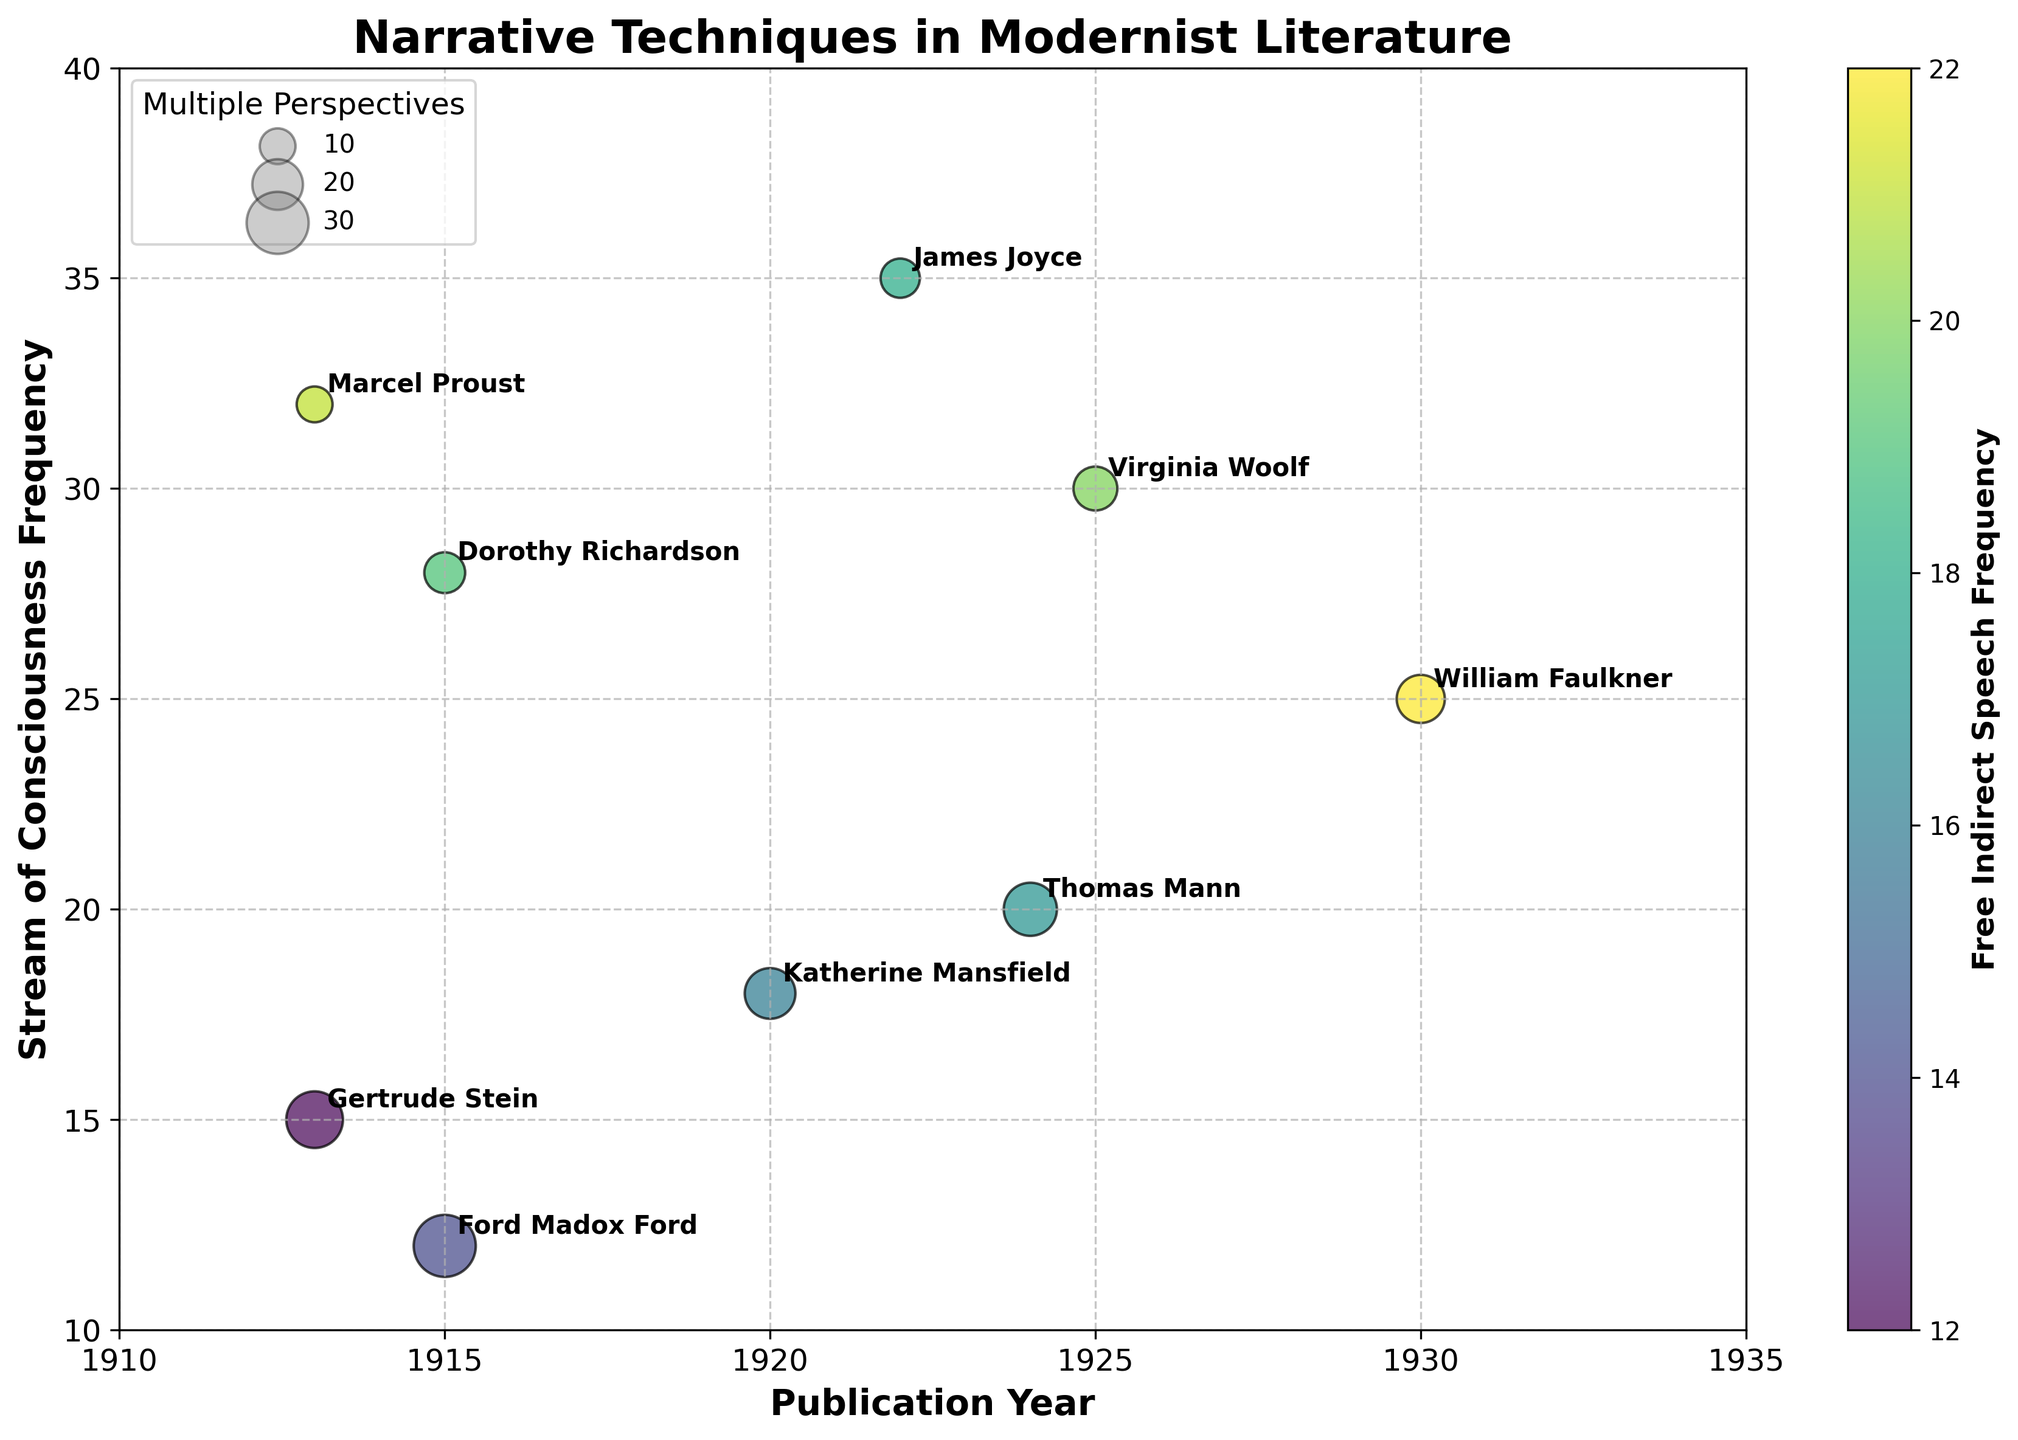What is the title of the figure? The title of the figure is usually placed at the top and it is meant to give a brief summary of what the chart conveys.
Answer: Narrative Techniques in Modernist Literature Which axis represents the Publication Year? The x-axis typically represents the independent variable, and here it is labeled as 'Publication Year'.
Answer: x-axis How many authors have data points in the figure? Each data point corresponds to an author, and we can count each label on the figure to determine the number of authors.
Answer: 9 Who used Stream of Consciousness most frequently? By identifying the highest value on the y-axis and checking the label, we find the author who utilized Stream of Consciousness most frequently. The highest value, 35, corresponds to James Joyce.
Answer: James Joyce Which author has the largest bubble size? The size of the bubbles represents 'Multiple Perspectives'; the largest bubble can be visually identified, which corresponds to the highest value. Ford Madox Ford has the largest bubble with a size of 30.
Answer: Ford Madox Ford How is Free Indirect Speech represented in the figure? Free Indirect Speech frequency is encoded using bubble colors, and a colorbar on the right side of the chart explains how the colors correspond to different values.
Answer: Bubble colors What is the range of the Stream of Consciousness frequency? To determine this range, we look for the minimum and maximum values of the y-axis, where Stream of Consciousness frequency is plotted. The range extends from about 10 to 35.
Answer: 10 to 35 Which year has the highest average use of Stream of Consciousness across authors? Calculate the average Stream of Consciousness for each unique year by summing the values and dividing by the number of authors for that year, check which year has the highest value. For instance, in 1925 Virginia Woolf has 30, and it is the only value for that year, thus 1925 is the highest year with an average of 30.
Answer: 1925 Does Katherine Mansfield have more instances of Multiple Perspectives than Virginia Woolf? Compare the size of the bubbles representing these authors. Katherine Mansfield's Multiple Perspectives value is 20, which is more than Virginia Woolf's 15.
Answer: Yes What is the general relationship between Stream of Consciousness and the publication year for the authors? By observing the overall trend of the bubbles along the x-axis and y-axis, we can infer if there is a pattern. The stream of consciousness frequencies are not strictly increasing or decreasing with publication year. It's indicated by scattered points.
Answer: No clear trend 